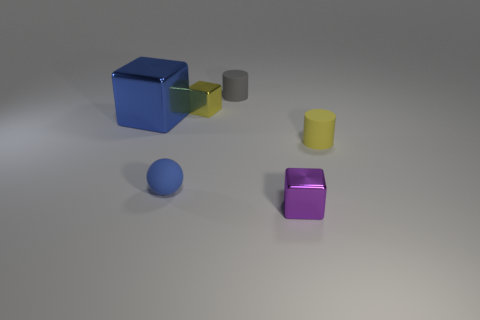There is a small rubber object that is right of the metal thing that is to the right of the yellow shiny thing; are there any small yellow objects left of it?
Your answer should be compact. Yes. There is a big block that is the same color as the rubber sphere; what material is it?
Keep it short and to the point. Metal. There is a matte object that is on the left side of the tiny gray matte cylinder; is it the same shape as the small rubber thing that is right of the purple object?
Your response must be concise. No. What material is the gray cylinder that is the same size as the blue sphere?
Your answer should be very brief. Rubber. Is the block that is in front of the small sphere made of the same material as the tiny yellow object to the right of the gray matte thing?
Your answer should be very brief. No. There is a yellow shiny thing that is the same size as the rubber ball; what is its shape?
Make the answer very short. Cube. How many other things are there of the same color as the sphere?
Your answer should be very brief. 1. The tiny metallic object in front of the tiny yellow rubber thing is what color?
Make the answer very short. Purple. How many other objects are there of the same material as the tiny yellow block?
Your answer should be very brief. 2. Is the number of yellow objects behind the small yellow matte object greater than the number of matte cylinders left of the large blue thing?
Make the answer very short. Yes. 